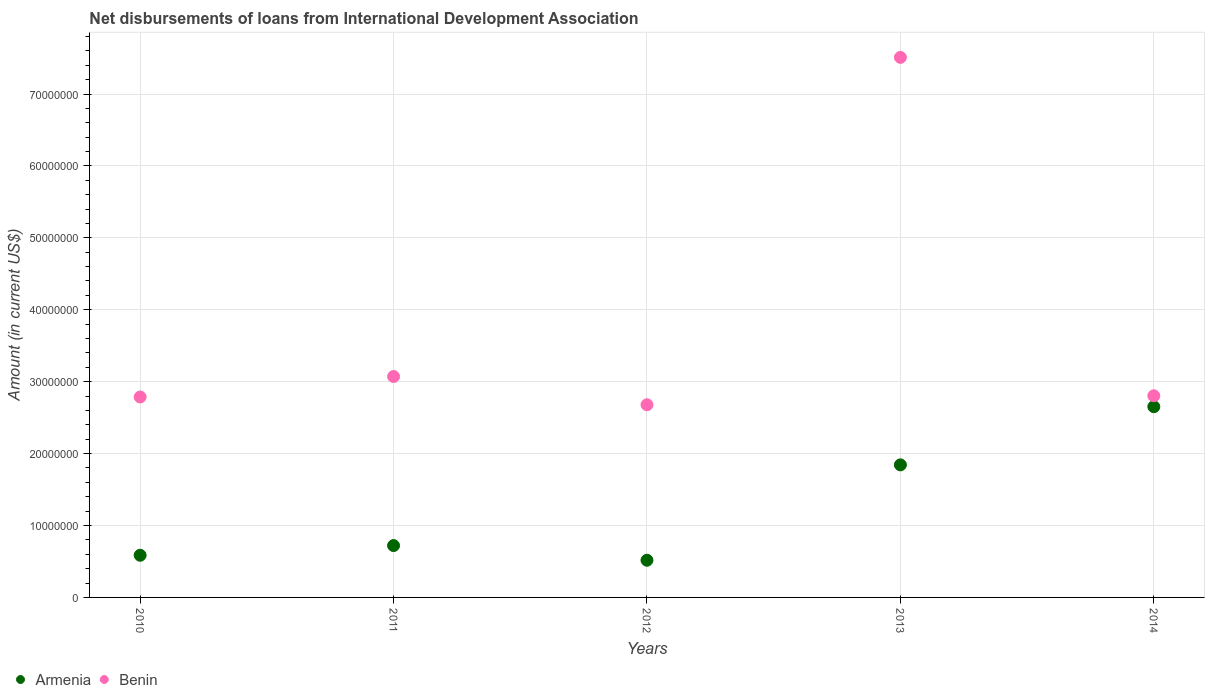How many different coloured dotlines are there?
Make the answer very short. 2. Is the number of dotlines equal to the number of legend labels?
Give a very brief answer. Yes. What is the amount of loans disbursed in Benin in 2013?
Keep it short and to the point. 7.51e+07. Across all years, what is the maximum amount of loans disbursed in Armenia?
Provide a succinct answer. 2.65e+07. Across all years, what is the minimum amount of loans disbursed in Armenia?
Provide a short and direct response. 5.17e+06. What is the total amount of loans disbursed in Benin in the graph?
Your answer should be compact. 1.89e+08. What is the difference between the amount of loans disbursed in Armenia in 2011 and that in 2013?
Ensure brevity in your answer.  -1.12e+07. What is the difference between the amount of loans disbursed in Armenia in 2011 and the amount of loans disbursed in Benin in 2013?
Your response must be concise. -6.79e+07. What is the average amount of loans disbursed in Armenia per year?
Your response must be concise. 1.26e+07. In the year 2010, what is the difference between the amount of loans disbursed in Armenia and amount of loans disbursed in Benin?
Make the answer very short. -2.20e+07. What is the ratio of the amount of loans disbursed in Armenia in 2012 to that in 2014?
Keep it short and to the point. 0.2. Is the difference between the amount of loans disbursed in Armenia in 2012 and 2014 greater than the difference between the amount of loans disbursed in Benin in 2012 and 2014?
Your response must be concise. No. What is the difference between the highest and the second highest amount of loans disbursed in Armenia?
Ensure brevity in your answer.  8.09e+06. What is the difference between the highest and the lowest amount of loans disbursed in Benin?
Keep it short and to the point. 4.83e+07. Is the amount of loans disbursed in Benin strictly greater than the amount of loans disbursed in Armenia over the years?
Offer a very short reply. Yes. How many dotlines are there?
Your response must be concise. 2. What is the difference between two consecutive major ticks on the Y-axis?
Offer a terse response. 1.00e+07. Are the values on the major ticks of Y-axis written in scientific E-notation?
Offer a very short reply. No. Where does the legend appear in the graph?
Offer a very short reply. Bottom left. What is the title of the graph?
Your answer should be compact. Net disbursements of loans from International Development Association. What is the label or title of the X-axis?
Offer a terse response. Years. What is the Amount (in current US$) of Armenia in 2010?
Your answer should be compact. 5.86e+06. What is the Amount (in current US$) of Benin in 2010?
Your response must be concise. 2.79e+07. What is the Amount (in current US$) of Armenia in 2011?
Offer a terse response. 7.21e+06. What is the Amount (in current US$) in Benin in 2011?
Provide a short and direct response. 3.07e+07. What is the Amount (in current US$) of Armenia in 2012?
Provide a short and direct response. 5.17e+06. What is the Amount (in current US$) in Benin in 2012?
Your response must be concise. 2.68e+07. What is the Amount (in current US$) of Armenia in 2013?
Your response must be concise. 1.84e+07. What is the Amount (in current US$) in Benin in 2013?
Ensure brevity in your answer.  7.51e+07. What is the Amount (in current US$) of Armenia in 2014?
Give a very brief answer. 2.65e+07. What is the Amount (in current US$) in Benin in 2014?
Provide a short and direct response. 2.80e+07. Across all years, what is the maximum Amount (in current US$) of Armenia?
Offer a terse response. 2.65e+07. Across all years, what is the maximum Amount (in current US$) of Benin?
Offer a very short reply. 7.51e+07. Across all years, what is the minimum Amount (in current US$) of Armenia?
Give a very brief answer. 5.17e+06. Across all years, what is the minimum Amount (in current US$) in Benin?
Ensure brevity in your answer.  2.68e+07. What is the total Amount (in current US$) in Armenia in the graph?
Ensure brevity in your answer.  6.32e+07. What is the total Amount (in current US$) of Benin in the graph?
Make the answer very short. 1.89e+08. What is the difference between the Amount (in current US$) of Armenia in 2010 and that in 2011?
Your answer should be very brief. -1.35e+06. What is the difference between the Amount (in current US$) of Benin in 2010 and that in 2011?
Your answer should be compact. -2.85e+06. What is the difference between the Amount (in current US$) in Armenia in 2010 and that in 2012?
Your answer should be compact. 6.91e+05. What is the difference between the Amount (in current US$) in Benin in 2010 and that in 2012?
Give a very brief answer. 1.08e+06. What is the difference between the Amount (in current US$) of Armenia in 2010 and that in 2013?
Offer a terse response. -1.26e+07. What is the difference between the Amount (in current US$) in Benin in 2010 and that in 2013?
Ensure brevity in your answer.  -4.72e+07. What is the difference between the Amount (in current US$) in Armenia in 2010 and that in 2014?
Offer a terse response. -2.07e+07. What is the difference between the Amount (in current US$) in Benin in 2010 and that in 2014?
Your answer should be very brief. -1.69e+05. What is the difference between the Amount (in current US$) in Armenia in 2011 and that in 2012?
Make the answer very short. 2.04e+06. What is the difference between the Amount (in current US$) of Benin in 2011 and that in 2012?
Provide a short and direct response. 3.92e+06. What is the difference between the Amount (in current US$) in Armenia in 2011 and that in 2013?
Make the answer very short. -1.12e+07. What is the difference between the Amount (in current US$) of Benin in 2011 and that in 2013?
Give a very brief answer. -4.44e+07. What is the difference between the Amount (in current US$) in Armenia in 2011 and that in 2014?
Keep it short and to the point. -1.93e+07. What is the difference between the Amount (in current US$) of Benin in 2011 and that in 2014?
Offer a very short reply. 2.68e+06. What is the difference between the Amount (in current US$) in Armenia in 2012 and that in 2013?
Provide a short and direct response. -1.33e+07. What is the difference between the Amount (in current US$) of Benin in 2012 and that in 2013?
Provide a short and direct response. -4.83e+07. What is the difference between the Amount (in current US$) in Armenia in 2012 and that in 2014?
Your response must be concise. -2.13e+07. What is the difference between the Amount (in current US$) of Benin in 2012 and that in 2014?
Make the answer very short. -1.24e+06. What is the difference between the Amount (in current US$) in Armenia in 2013 and that in 2014?
Provide a succinct answer. -8.09e+06. What is the difference between the Amount (in current US$) of Benin in 2013 and that in 2014?
Provide a succinct answer. 4.71e+07. What is the difference between the Amount (in current US$) of Armenia in 2010 and the Amount (in current US$) of Benin in 2011?
Your answer should be compact. -2.49e+07. What is the difference between the Amount (in current US$) in Armenia in 2010 and the Amount (in current US$) in Benin in 2012?
Give a very brief answer. -2.09e+07. What is the difference between the Amount (in current US$) in Armenia in 2010 and the Amount (in current US$) in Benin in 2013?
Give a very brief answer. -6.92e+07. What is the difference between the Amount (in current US$) in Armenia in 2010 and the Amount (in current US$) in Benin in 2014?
Your response must be concise. -2.22e+07. What is the difference between the Amount (in current US$) in Armenia in 2011 and the Amount (in current US$) in Benin in 2012?
Your answer should be compact. -1.96e+07. What is the difference between the Amount (in current US$) of Armenia in 2011 and the Amount (in current US$) of Benin in 2013?
Make the answer very short. -6.79e+07. What is the difference between the Amount (in current US$) in Armenia in 2011 and the Amount (in current US$) in Benin in 2014?
Ensure brevity in your answer.  -2.08e+07. What is the difference between the Amount (in current US$) of Armenia in 2012 and the Amount (in current US$) of Benin in 2013?
Make the answer very short. -6.99e+07. What is the difference between the Amount (in current US$) of Armenia in 2012 and the Amount (in current US$) of Benin in 2014?
Provide a short and direct response. -2.29e+07. What is the difference between the Amount (in current US$) of Armenia in 2013 and the Amount (in current US$) of Benin in 2014?
Provide a short and direct response. -9.61e+06. What is the average Amount (in current US$) in Armenia per year?
Offer a very short reply. 1.26e+07. What is the average Amount (in current US$) in Benin per year?
Your answer should be compact. 3.77e+07. In the year 2010, what is the difference between the Amount (in current US$) of Armenia and Amount (in current US$) of Benin?
Your answer should be very brief. -2.20e+07. In the year 2011, what is the difference between the Amount (in current US$) of Armenia and Amount (in current US$) of Benin?
Give a very brief answer. -2.35e+07. In the year 2012, what is the difference between the Amount (in current US$) of Armenia and Amount (in current US$) of Benin?
Keep it short and to the point. -2.16e+07. In the year 2013, what is the difference between the Amount (in current US$) in Armenia and Amount (in current US$) in Benin?
Your response must be concise. -5.67e+07. In the year 2014, what is the difference between the Amount (in current US$) of Armenia and Amount (in current US$) of Benin?
Offer a very short reply. -1.52e+06. What is the ratio of the Amount (in current US$) of Armenia in 2010 to that in 2011?
Ensure brevity in your answer.  0.81. What is the ratio of the Amount (in current US$) in Benin in 2010 to that in 2011?
Ensure brevity in your answer.  0.91. What is the ratio of the Amount (in current US$) in Armenia in 2010 to that in 2012?
Your answer should be compact. 1.13. What is the ratio of the Amount (in current US$) of Benin in 2010 to that in 2012?
Offer a very short reply. 1.04. What is the ratio of the Amount (in current US$) of Armenia in 2010 to that in 2013?
Make the answer very short. 0.32. What is the ratio of the Amount (in current US$) in Benin in 2010 to that in 2013?
Your answer should be compact. 0.37. What is the ratio of the Amount (in current US$) in Armenia in 2010 to that in 2014?
Offer a very short reply. 0.22. What is the ratio of the Amount (in current US$) in Benin in 2010 to that in 2014?
Make the answer very short. 0.99. What is the ratio of the Amount (in current US$) of Armenia in 2011 to that in 2012?
Give a very brief answer. 1.39. What is the ratio of the Amount (in current US$) of Benin in 2011 to that in 2012?
Provide a succinct answer. 1.15. What is the ratio of the Amount (in current US$) of Armenia in 2011 to that in 2013?
Keep it short and to the point. 0.39. What is the ratio of the Amount (in current US$) of Benin in 2011 to that in 2013?
Provide a succinct answer. 0.41. What is the ratio of the Amount (in current US$) in Armenia in 2011 to that in 2014?
Make the answer very short. 0.27. What is the ratio of the Amount (in current US$) of Benin in 2011 to that in 2014?
Provide a short and direct response. 1.1. What is the ratio of the Amount (in current US$) in Armenia in 2012 to that in 2013?
Your answer should be very brief. 0.28. What is the ratio of the Amount (in current US$) in Benin in 2012 to that in 2013?
Your answer should be very brief. 0.36. What is the ratio of the Amount (in current US$) in Armenia in 2012 to that in 2014?
Keep it short and to the point. 0.2. What is the ratio of the Amount (in current US$) of Benin in 2012 to that in 2014?
Offer a very short reply. 0.96. What is the ratio of the Amount (in current US$) of Armenia in 2013 to that in 2014?
Ensure brevity in your answer.  0.69. What is the ratio of the Amount (in current US$) of Benin in 2013 to that in 2014?
Ensure brevity in your answer.  2.68. What is the difference between the highest and the second highest Amount (in current US$) in Armenia?
Provide a short and direct response. 8.09e+06. What is the difference between the highest and the second highest Amount (in current US$) in Benin?
Your answer should be compact. 4.44e+07. What is the difference between the highest and the lowest Amount (in current US$) of Armenia?
Your response must be concise. 2.13e+07. What is the difference between the highest and the lowest Amount (in current US$) in Benin?
Your answer should be compact. 4.83e+07. 